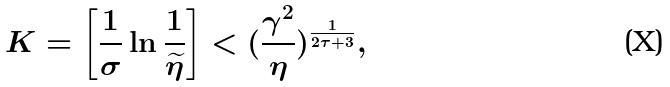Convert formula to latex. <formula><loc_0><loc_0><loc_500><loc_500>K = \left [ \frac { 1 } { \sigma } \ln \frac { 1 } { \widetilde { \eta } } \right ] < ( \frac { \gamma ^ { 2 } } { \eta } ) ^ { \frac { 1 } { 2 \tau + 3 } } ,</formula> 